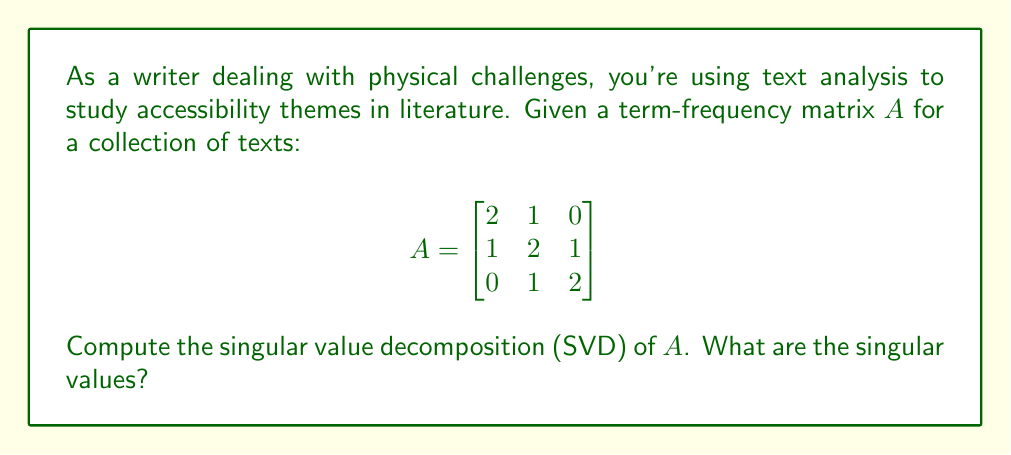Teach me how to tackle this problem. To compute the singular value decomposition (SVD) of matrix $A$, we follow these steps:

1) First, calculate $A^TA$ and $AA^T$:

   $$A^TA = \begin{bmatrix}
   5 & 4 & 2 \\
   4 & 6 & 4 \\
   2 & 4 & 5
   \end{bmatrix}$$

   $$AA^T = \begin{bmatrix}
   5 & 4 & 1 \\
   4 & 6 & 4 \\
   1 & 4 & 5
   \end{bmatrix}$$

2) Find the eigenvalues of $A^TA$ (or $AA^T$, they're the same):
   Characteristic equation: $\det(A^TA - \lambda I) = 0$
   $$(5-\lambda)(6-\lambda)(5-\lambda) - 16(5-\lambda) - 16(6-\lambda) - 4(5-\lambda) + 32 + 32 + 8 = 0$$
   $$-\lambda^3 + 16\lambda^2 - 71\lambda + 90 = 0$$

   Solving this equation gives eigenvalues: $\lambda_1 = 9, \lambda_2 = 6, \lambda_3 = 1$

3) The singular values are the square roots of these eigenvalues:
   $$\sigma_1 = \sqrt{9} = 3$$
   $$\sigma_2 = \sqrt{6} \approx 2.45$$
   $$\sigma_3 = \sqrt{1} = 1$$

4) The full SVD is $A = U\Sigma V^T$, where $U$ and $V$ are orthogonal matrices containing left and right singular vectors, and $\Sigma$ is a diagonal matrix with singular values. However, finding $U$ and $V$ is not necessary to answer the question about singular values.
Answer: $3, \sqrt{6}, 1$ 